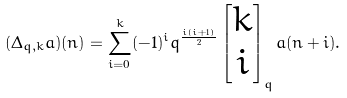Convert formula to latex. <formula><loc_0><loc_0><loc_500><loc_500>( \Delta _ { q , k } a ) ( n ) = \sum _ { i = 0 } ^ { k } ( - 1 ) ^ { i } q ^ { \frac { i ( i + 1 ) } { 2 } } \begin{bmatrix} k \\ i \end{bmatrix} _ { q } a ( n + i ) .</formula> 